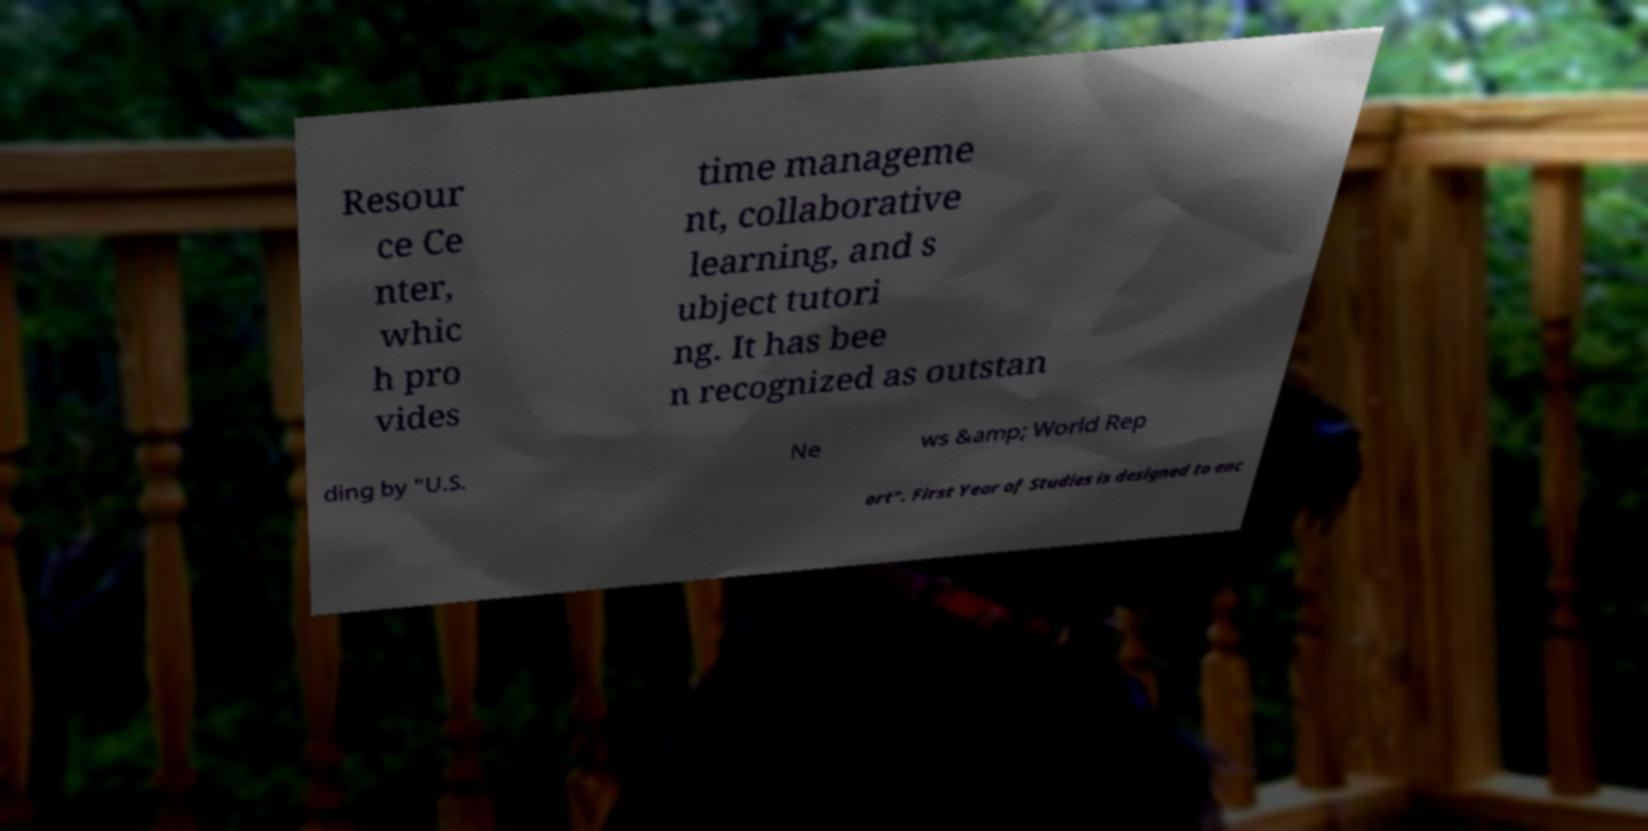Could you assist in decoding the text presented in this image and type it out clearly? Resour ce Ce nter, whic h pro vides time manageme nt, collaborative learning, and s ubject tutori ng. It has bee n recognized as outstan ding by "U.S. Ne ws &amp; World Rep ort". First Year of Studies is designed to enc 